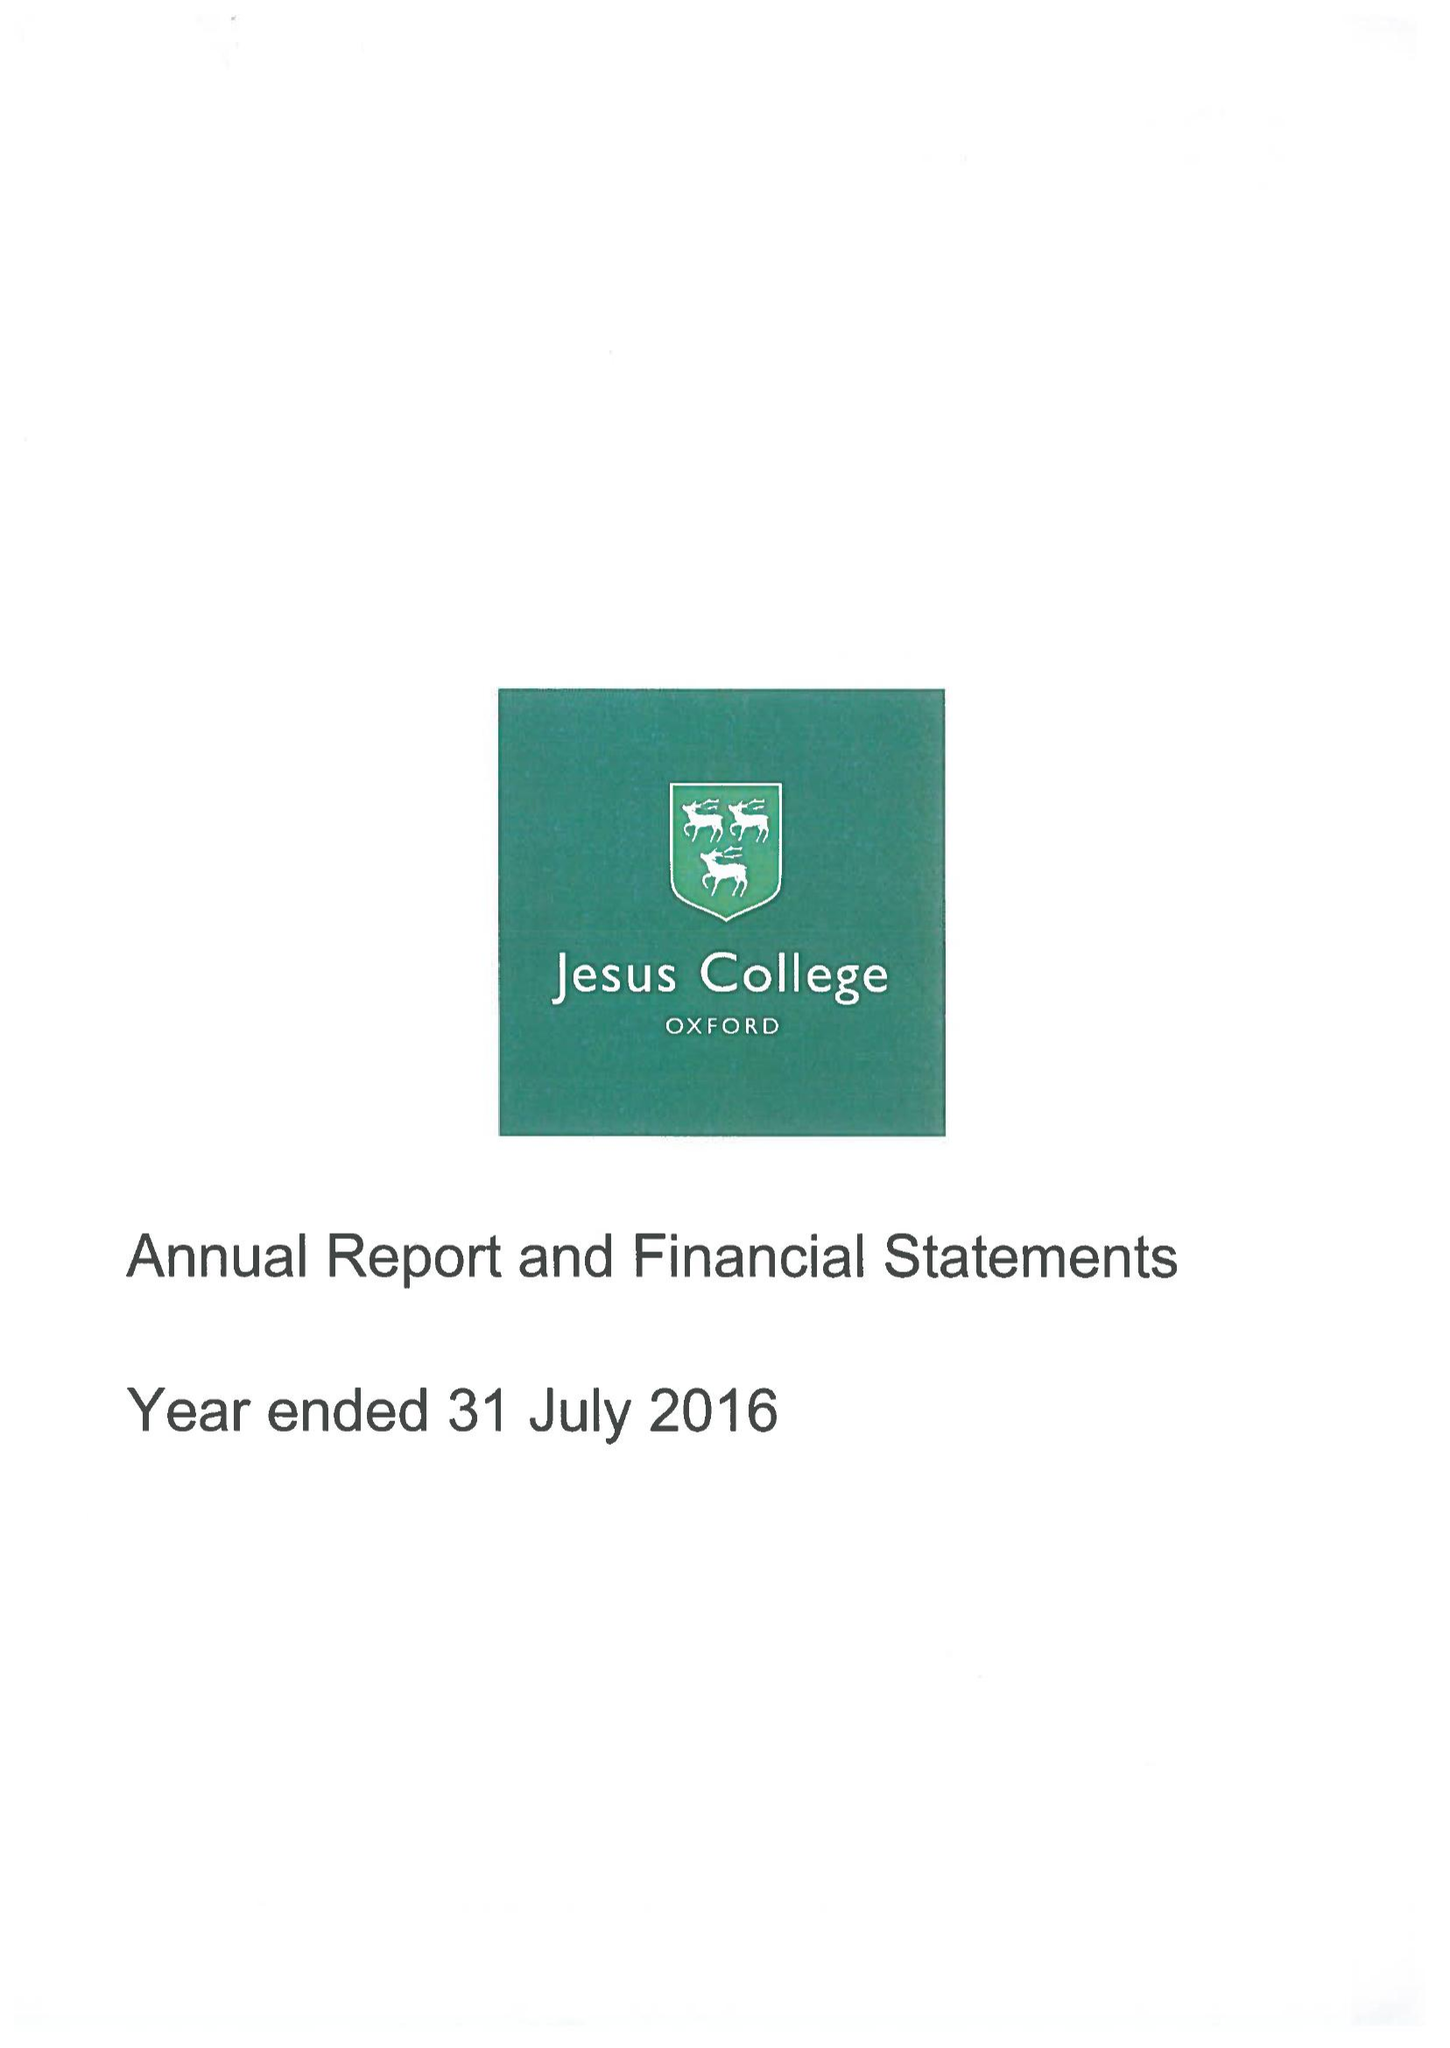What is the value for the address__post_town?
Answer the question using a single word or phrase. OXFORD 